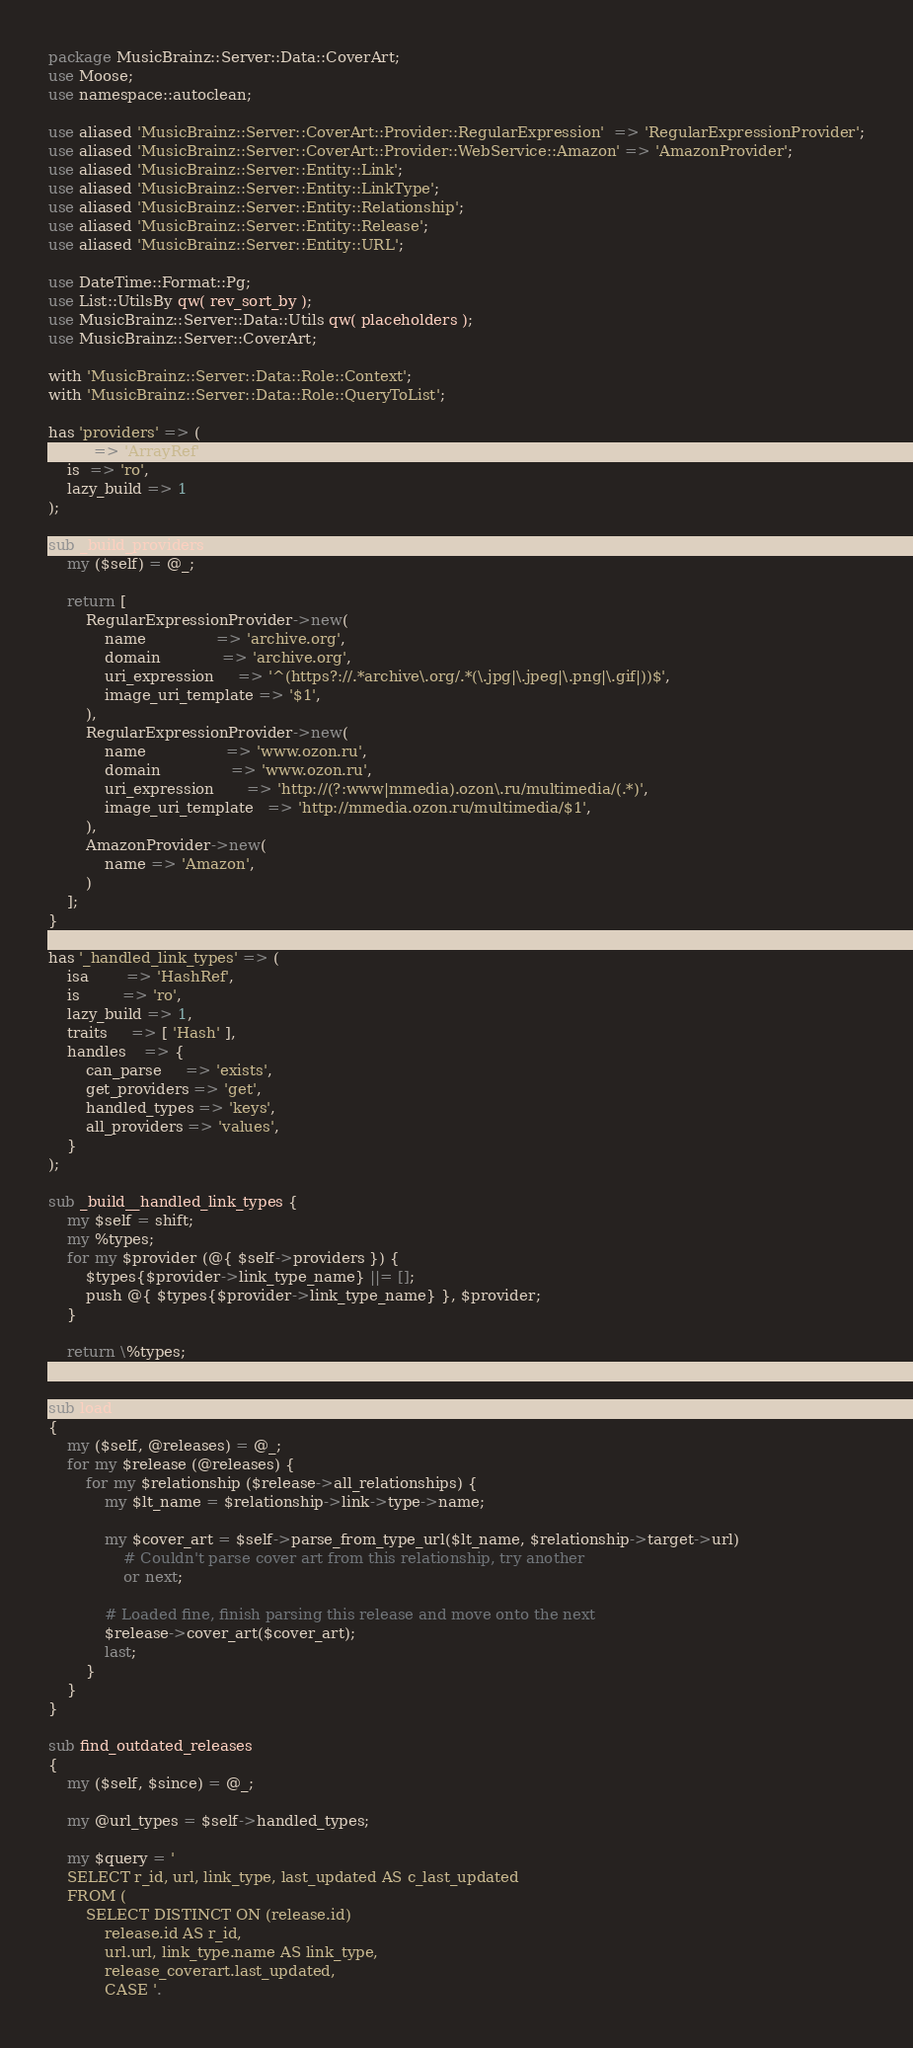Convert code to text. <code><loc_0><loc_0><loc_500><loc_500><_Perl_>package MusicBrainz::Server::Data::CoverArt;
use Moose;
use namespace::autoclean;

use aliased 'MusicBrainz::Server::CoverArt::Provider::RegularExpression'  => 'RegularExpressionProvider';
use aliased 'MusicBrainz::Server::CoverArt::Provider::WebService::Amazon' => 'AmazonProvider';
use aliased 'MusicBrainz::Server::Entity::Link';
use aliased 'MusicBrainz::Server::Entity::LinkType';
use aliased 'MusicBrainz::Server::Entity::Relationship';
use aliased 'MusicBrainz::Server::Entity::Release';
use aliased 'MusicBrainz::Server::Entity::URL';

use DateTime::Format::Pg;
use List::UtilsBy qw( rev_sort_by );
use MusicBrainz::Server::Data::Utils qw( placeholders );
use MusicBrainz::Server::CoverArt;

with 'MusicBrainz::Server::Data::Role::Context';
with 'MusicBrainz::Server::Data::Role::QueryToList';

has 'providers' => (
    isa => 'ArrayRef',
    is  => 'ro',
    lazy_build => 1
);

sub _build_providers {
    my ($self) = @_;

    return [
        RegularExpressionProvider->new(
            name               => 'archive.org',
            domain             => 'archive.org',
            uri_expression     => '^(https?://.*archive\.org/.*(\.jpg|\.jpeg|\.png|\.gif|))$',
            image_uri_template => '$1',
        ),
        RegularExpressionProvider->new(
            name                 => 'www.ozon.ru',
            domain               => 'www.ozon.ru',
            uri_expression       => 'http://(?:www|mmedia).ozon\.ru/multimedia/(.*)',
            image_uri_template   => 'http://mmedia.ozon.ru/multimedia/$1',
        ),
        AmazonProvider->new(
            name => 'Amazon',
        )
    ];
}

has '_handled_link_types' => (
    isa        => 'HashRef',
    is         => 'ro',
    lazy_build => 1,
    traits     => [ 'Hash' ],
    handles    => {
        can_parse     => 'exists',
        get_providers => 'get',
        handled_types => 'keys',
        all_providers => 'values',
    }
);

sub _build__handled_link_types {
    my $self = shift;
    my %types;
    for my $provider (@{ $self->providers }) {
        $types{$provider->link_type_name} ||= [];
        push @{ $types{$provider->link_type_name} }, $provider;
    }

    return \%types;
}

sub load
{
    my ($self, @releases) = @_;
    for my $release (@releases) {
        for my $relationship ($release->all_relationships) {
            my $lt_name = $relationship->link->type->name;

            my $cover_art = $self->parse_from_type_url($lt_name, $relationship->target->url)
                # Couldn't parse cover art from this relationship, try another
                or next;

            # Loaded fine, finish parsing this release and move onto the next
            $release->cover_art($cover_art);
            last;
        }
    }
}

sub find_outdated_releases
{
    my ($self, $since) = @_;

    my @url_types = $self->handled_types;

    my $query = '
    SELECT r_id, url, link_type, last_updated AS c_last_updated
    FROM (
        SELECT DISTINCT ON (release.id)
            release.id AS r_id,
            url.url, link_type.name AS link_type,
            release_coverart.last_updated,
            CASE '.</code> 